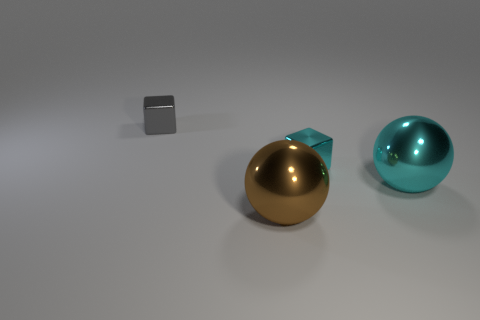There is a sphere to the left of the sphere that is behind the big shiny thing that is in front of the large cyan object; how big is it? The sphere to the left is moderately sized, smaller than the large cyan object that it's in front of, but larger than the small cube to its left. It appears to be made of a reflective material with a gold finish, distinguishing its reflective quality from the nearby objects due to the contrast in size and color. 